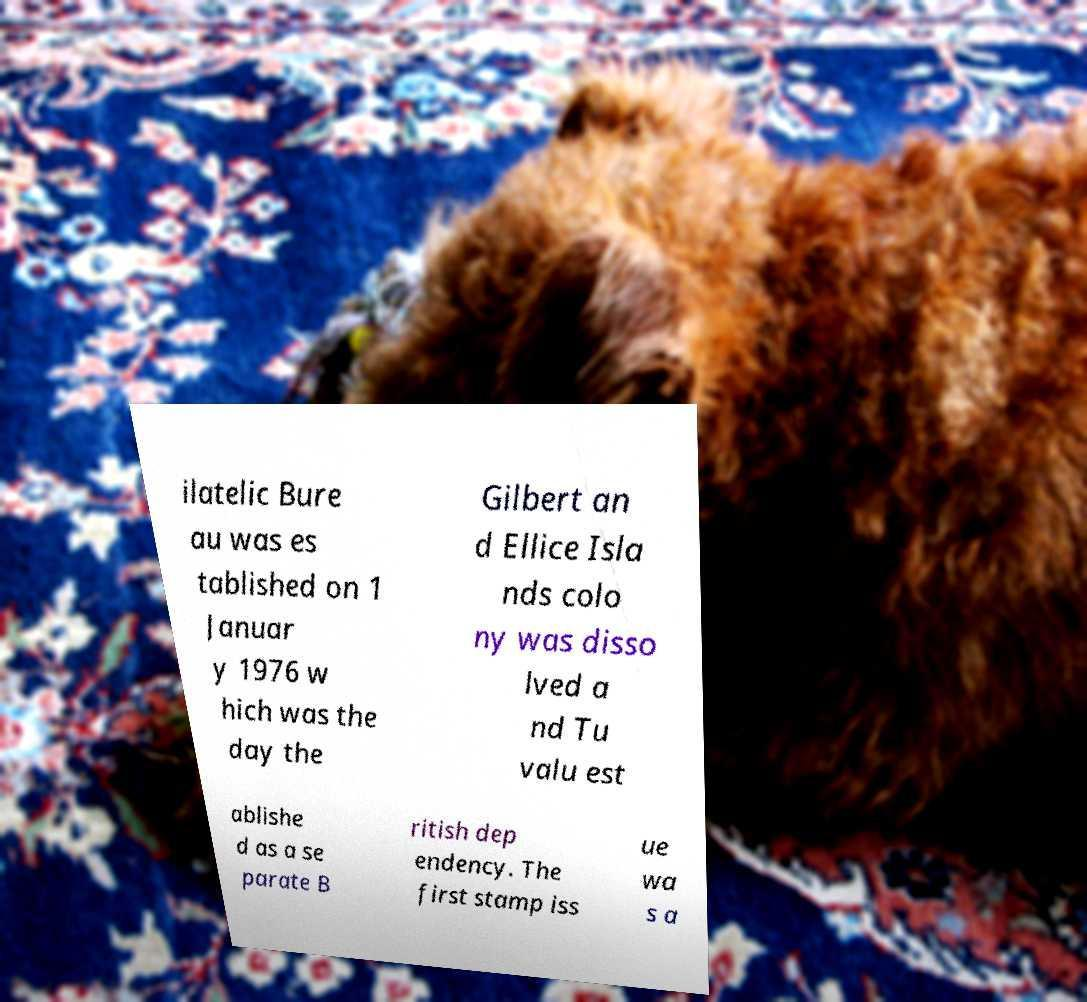Could you assist in decoding the text presented in this image and type it out clearly? ilatelic Bure au was es tablished on 1 Januar y 1976 w hich was the day the Gilbert an d Ellice Isla nds colo ny was disso lved a nd Tu valu est ablishe d as a se parate B ritish dep endency. The first stamp iss ue wa s a 